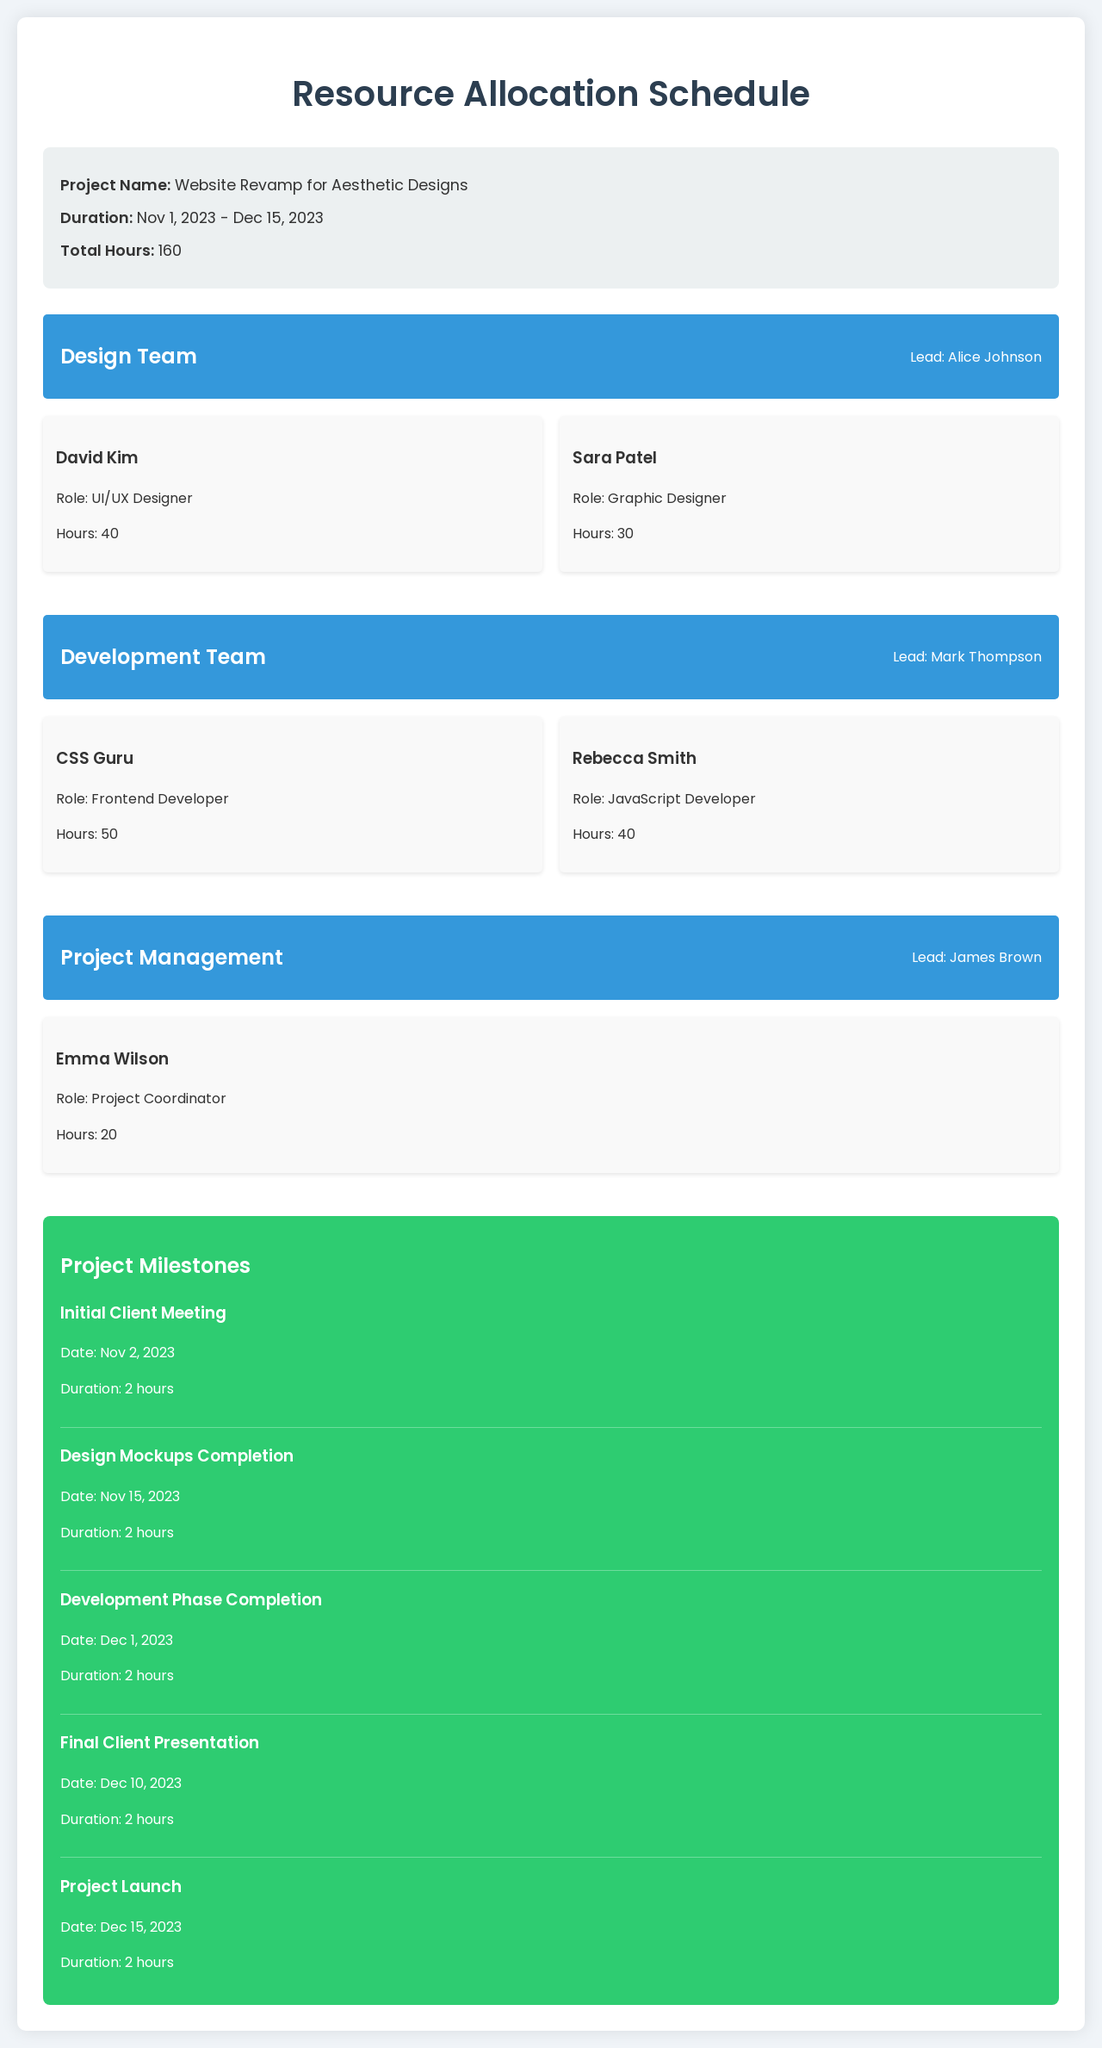What is the project name? The project name is specified in the document under the project info section.
Answer: Website Revamp for Aesthetic Designs What are the total hours allocated for the project? The total hours are found in the project info section, which summarizes the overall time for the project.
Answer: 160 Who is the lead for the Design Team? The lead for the Design Team is mentioned at the top of the respective section.
Answer: Alice Johnson How many hours is the CSS Guru allocated? The CSS Guru's hours are listed under the Development Team section.
Answer: 50 When is the Initial Client Meeting scheduled? The schedule lists specific dates for milestones, including the first meeting.
Answer: Nov 2, 2023 Which role does Emma Wilson fulfill? Emma Wilson’s role is stated in the Project Management section.
Answer: Project Coordinator What is the duration of the Design Mockups Completion? The duration is detailed under the milestones section for that specific task.
Answer: 2 hours Are there any tasks scheduled for Dec 15, 2023? The document outlines milestones with corresponding dates, including that date.
Answer: Yes, Project Launch How many team members are in the Development Team? The total number of team members is counted in the Development Team section.
Answer: 2 